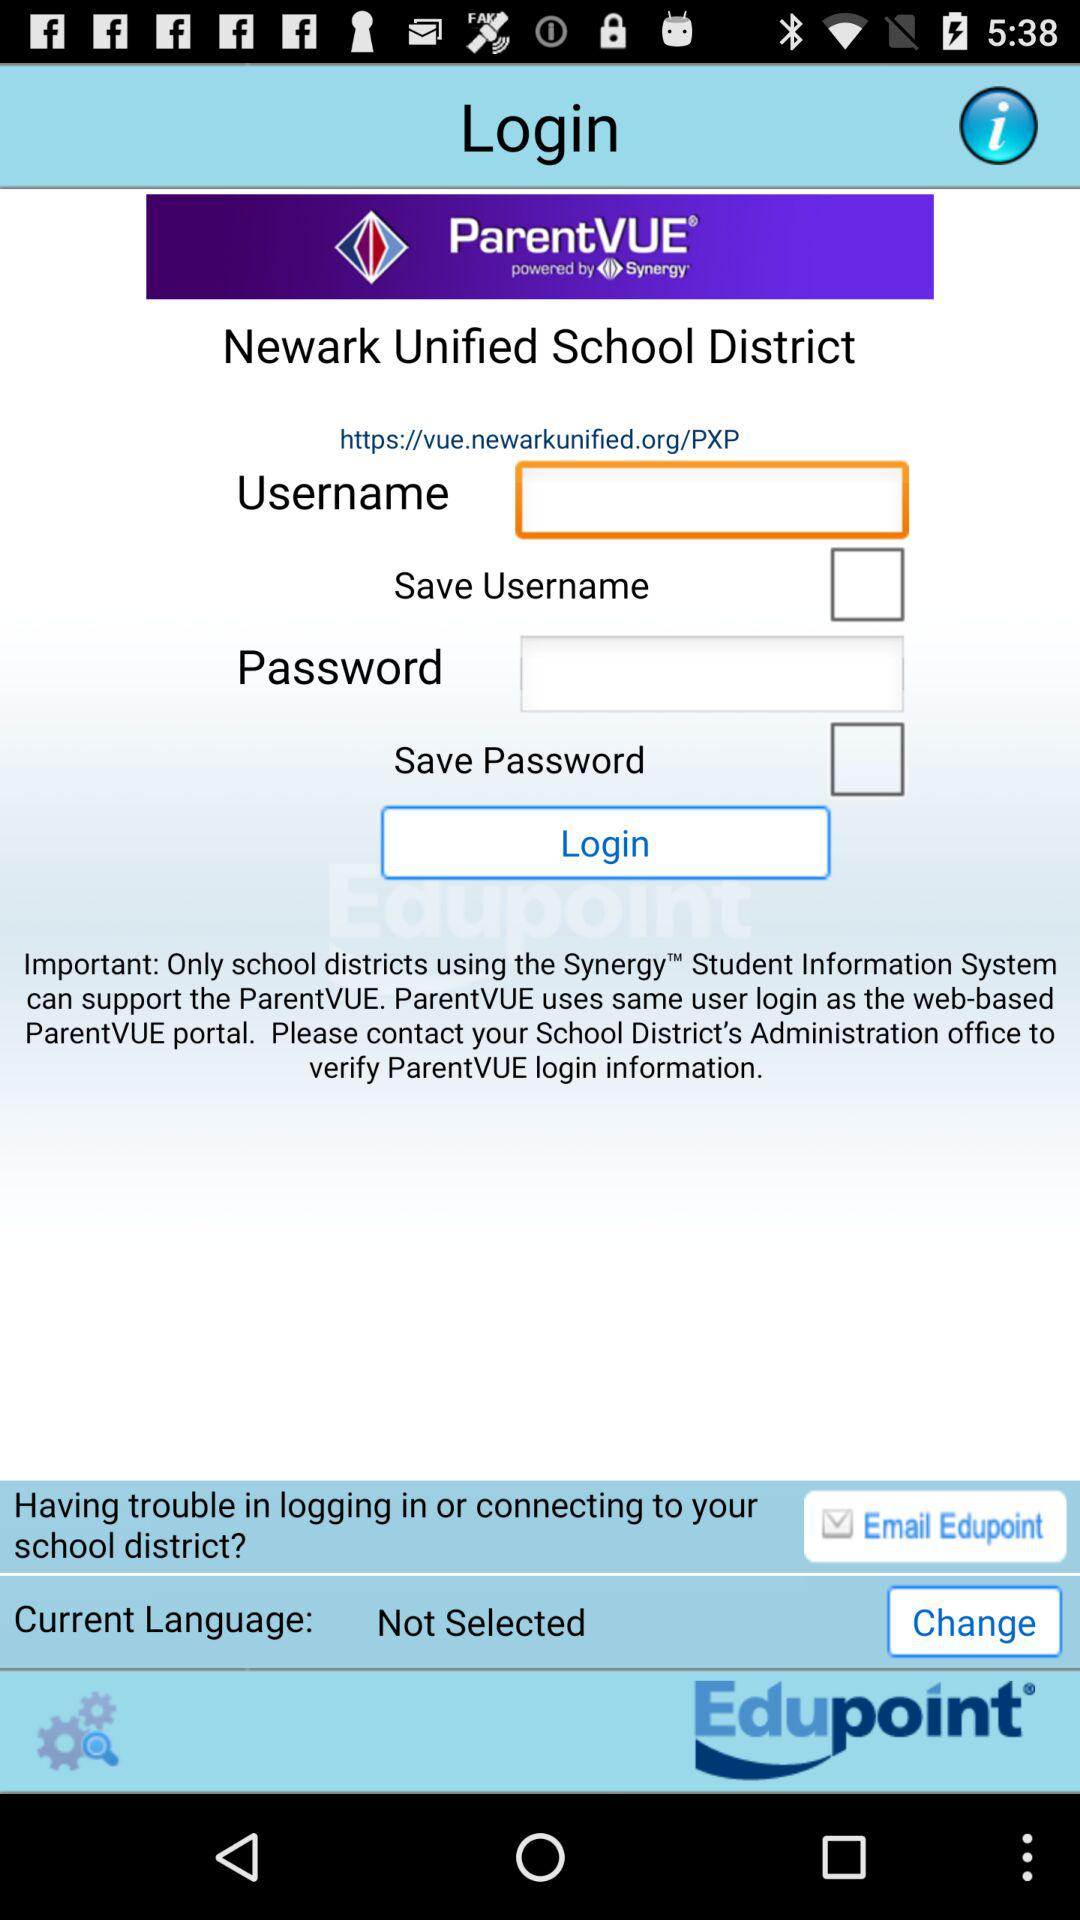What is the name of the application? The name of the application is "ParentVue". 